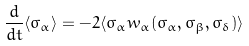<formula> <loc_0><loc_0><loc_500><loc_500>\frac { d } { d t } \langle \sigma _ { \alpha } \rangle = - 2 \langle \sigma _ { \alpha } w _ { \alpha } ( \sigma _ { \alpha } , \sigma _ { \beta } , \sigma _ { \delta } ) \rangle</formula> 